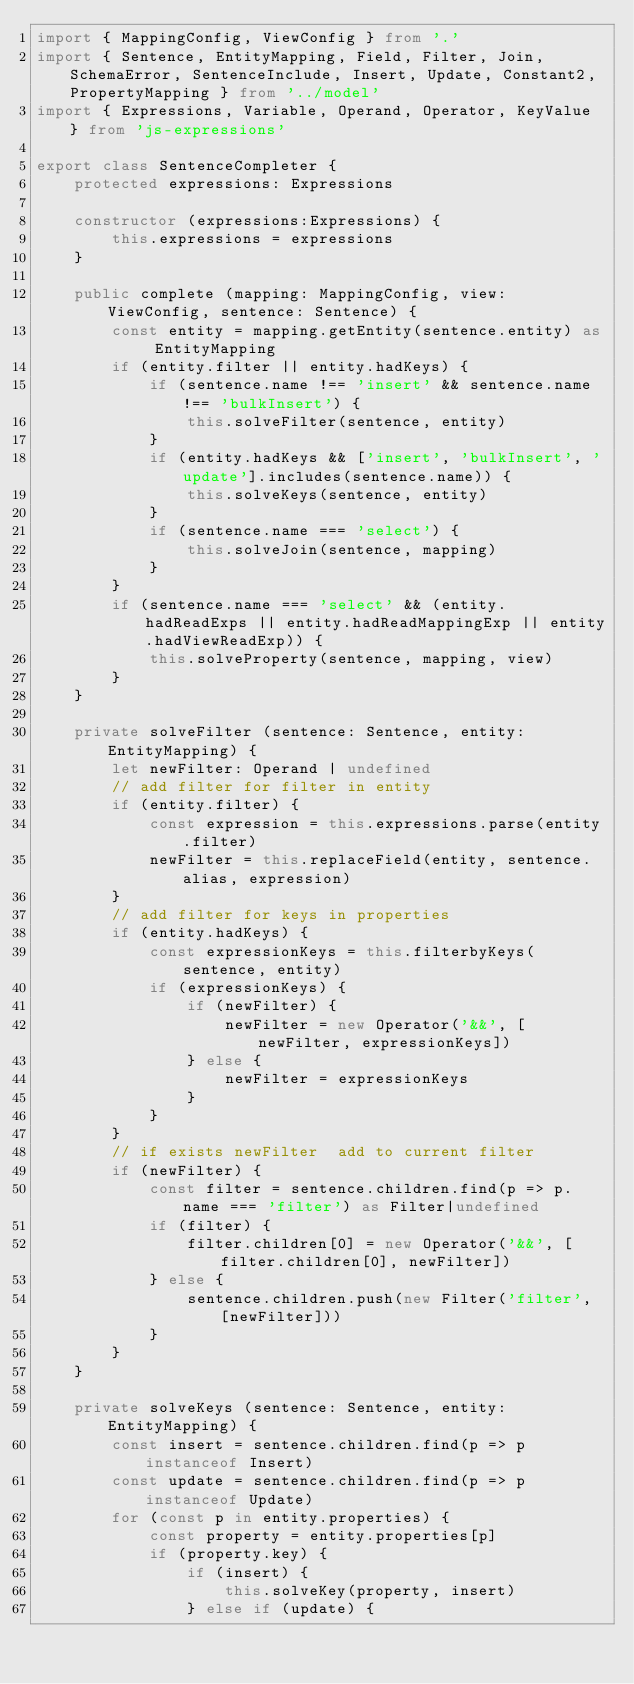<code> <loc_0><loc_0><loc_500><loc_500><_TypeScript_>import { MappingConfig, ViewConfig } from '.'
import { Sentence, EntityMapping, Field, Filter, Join, SchemaError, SentenceInclude, Insert, Update, Constant2, PropertyMapping } from '../model'
import { Expressions, Variable, Operand, Operator, KeyValue } from 'js-expressions'

export class SentenceCompleter {
	protected expressions: Expressions

	constructor (expressions:Expressions) {
		this.expressions = expressions
	}

	public complete (mapping: MappingConfig, view: ViewConfig, sentence: Sentence) {
		const entity = mapping.getEntity(sentence.entity) as EntityMapping
		if (entity.filter || entity.hadKeys) {
			if (sentence.name !== 'insert' && sentence.name !== 'bulkInsert') {
				this.solveFilter(sentence, entity)
			}
			if (entity.hadKeys && ['insert', 'bulkInsert', 'update'].includes(sentence.name)) {
				this.solveKeys(sentence, entity)
			}
			if (sentence.name === 'select') {
				this.solveJoin(sentence, mapping)
			}
		}
		if (sentence.name === 'select' && (entity.hadReadExps || entity.hadReadMappingExp || entity.hadViewReadExp)) {
			this.solveProperty(sentence, mapping, view)
		}
	}

	private solveFilter (sentence: Sentence, entity: EntityMapping) {
		let newFilter: Operand | undefined
		// add filter for filter in entity
		if (entity.filter) {
			const expression = this.expressions.parse(entity.filter)
			newFilter = this.replaceField(entity, sentence.alias, expression)
		}
		// add filter for keys in properties
		if (entity.hadKeys) {
			const expressionKeys = this.filterbyKeys(sentence, entity)
			if (expressionKeys) {
				if (newFilter) {
					newFilter = new Operator('&&', [newFilter, expressionKeys])
				} else {
					newFilter = expressionKeys
				}
			}
		}
		// if exists newFilter  add to current filter
		if (newFilter) {
			const filter = sentence.children.find(p => p.name === 'filter') as Filter|undefined
			if (filter) {
				filter.children[0] = new Operator('&&', [filter.children[0], newFilter])
			} else {
				sentence.children.push(new Filter('filter', [newFilter]))
			}
		}
	}

	private solveKeys (sentence: Sentence, entity: EntityMapping) {
		const insert = sentence.children.find(p => p instanceof Insert)
		const update = sentence.children.find(p => p instanceof Update)
		for (const p in entity.properties) {
			const property = entity.properties[p]
			if (property.key) {
				if (insert) {
					this.solveKey(property, insert)
				} else if (update) {</code> 